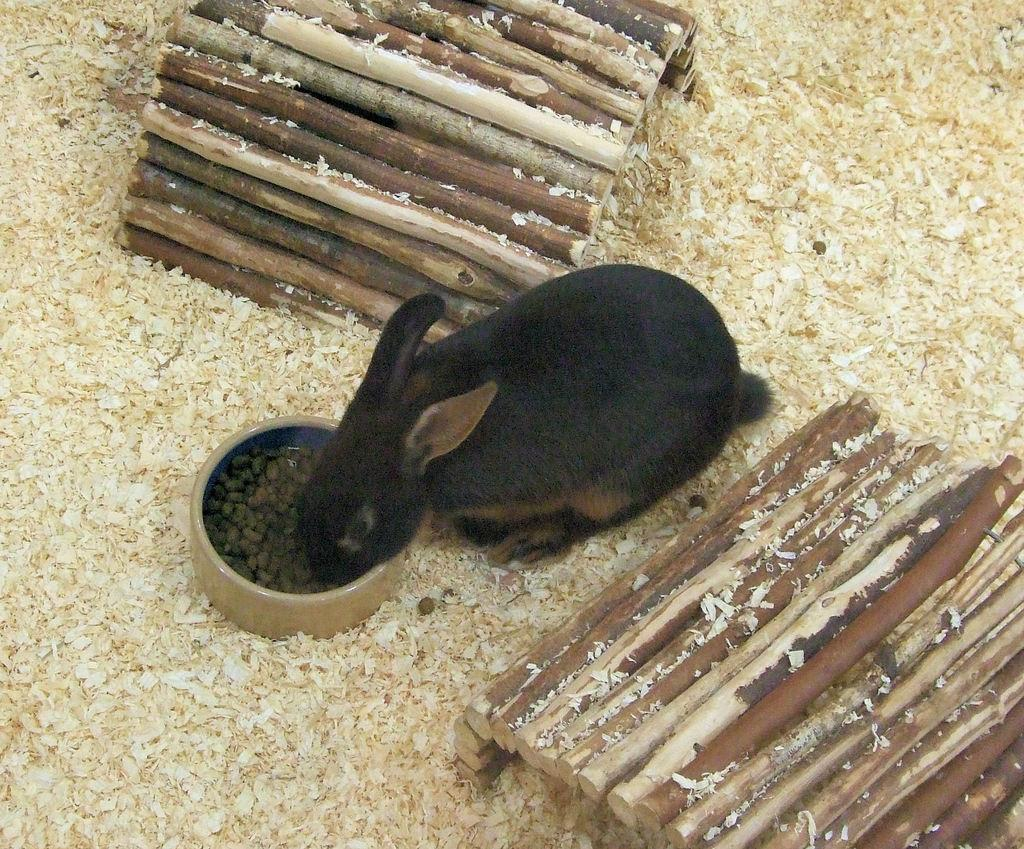What animal can be seen in the image? There is a rabbit in the image. What is the rabbit doing in the image? The rabbit is eating food in the image. What type of structures are present in the image? There are wooden burrows in the image. What flavor of breath can be smelled from the rabbit in the image? There is no indication of the rabbit's breath in the image, so it cannot be determined. 